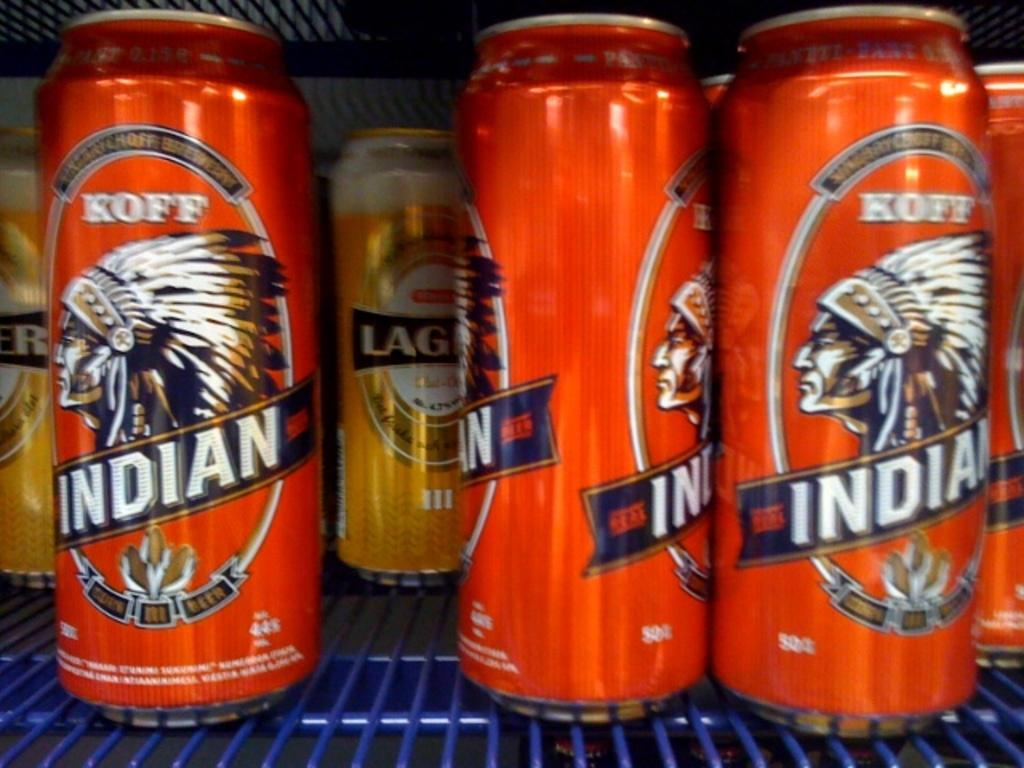Provide a one-sentence caption for the provided image. Several orange cans of Koff indian beer sitting on a blue shelf. 